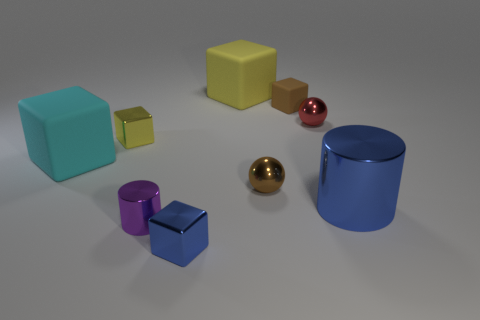Subtract all brown cubes. How many cubes are left? 4 Subtract all tiny brown cubes. How many cubes are left? 4 Subtract all gray blocks. Subtract all red cylinders. How many blocks are left? 5 Subtract all blocks. How many objects are left? 4 Add 6 cylinders. How many cylinders are left? 8 Add 3 yellow spheres. How many yellow spheres exist? 3 Subtract 0 red cubes. How many objects are left? 9 Subtract all brown spheres. Subtract all small yellow metal blocks. How many objects are left? 7 